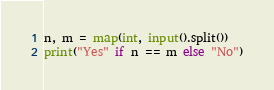<code> <loc_0><loc_0><loc_500><loc_500><_Python_>n, m = map(int, input().split())
print("Yes" if n == m else "No")</code> 